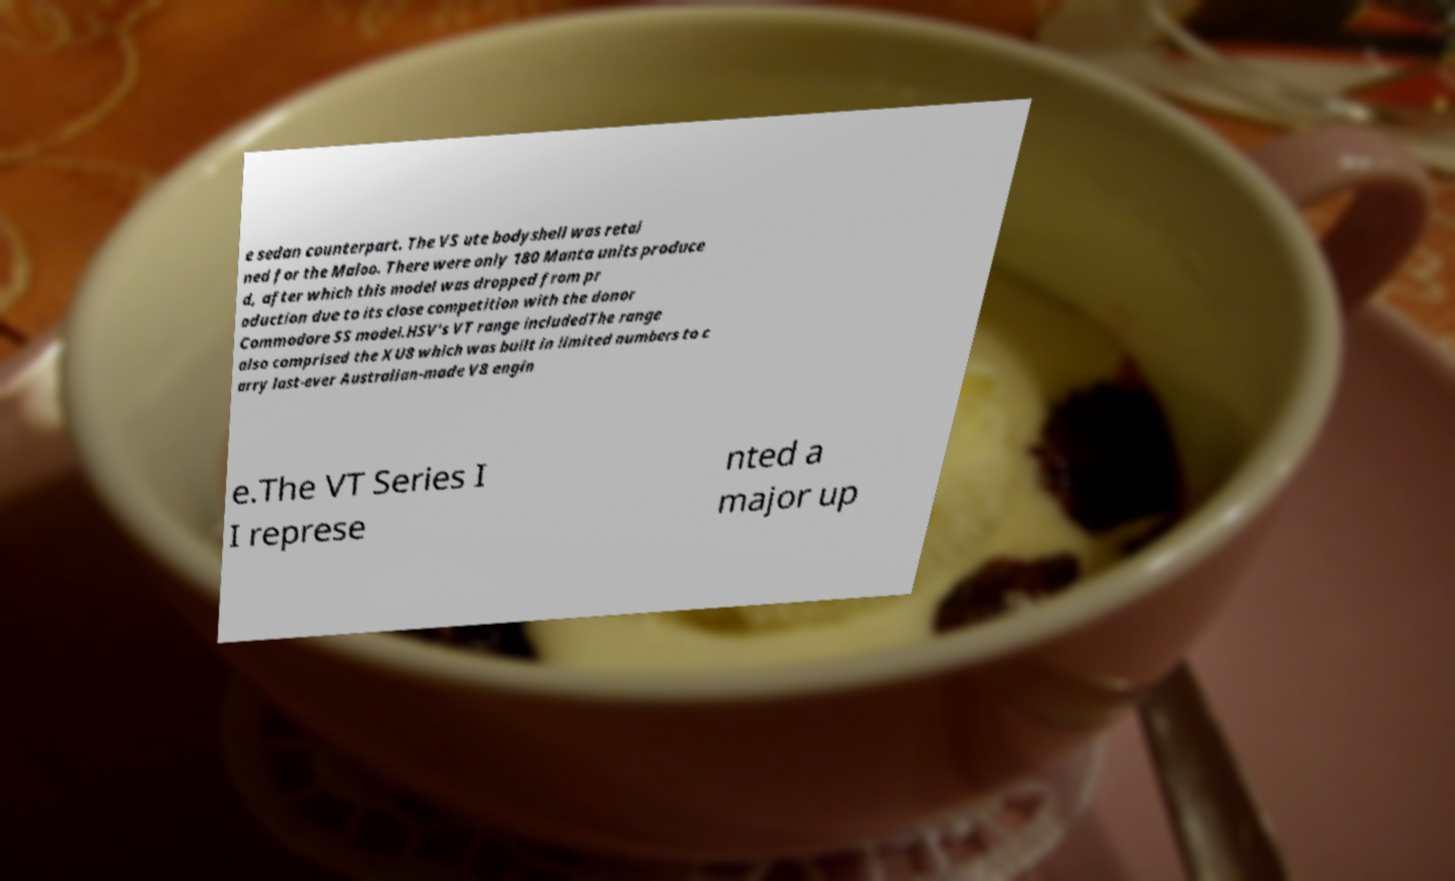I need the written content from this picture converted into text. Can you do that? e sedan counterpart. The VS ute bodyshell was retai ned for the Maloo. There were only 180 Manta units produce d, after which this model was dropped from pr oduction due to its close competition with the donor Commodore SS model.HSV's VT range includedThe range also comprised the XU8 which was built in limited numbers to c arry last-ever Australian-made V8 engin e.The VT Series I I represe nted a major up 